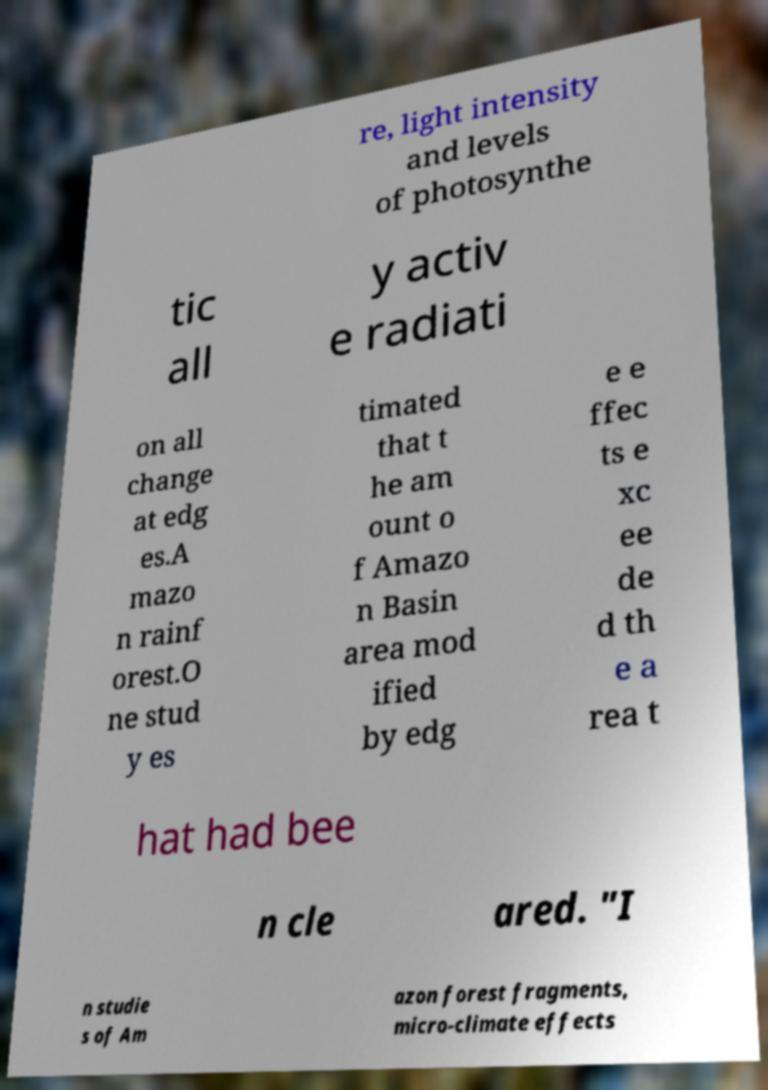Could you assist in decoding the text presented in this image and type it out clearly? re, light intensity and levels of photosynthe tic all y activ e radiati on all change at edg es.A mazo n rainf orest.O ne stud y es timated that t he am ount o f Amazo n Basin area mod ified by edg e e ffec ts e xc ee de d th e a rea t hat had bee n cle ared. "I n studie s of Am azon forest fragments, micro-climate effects 